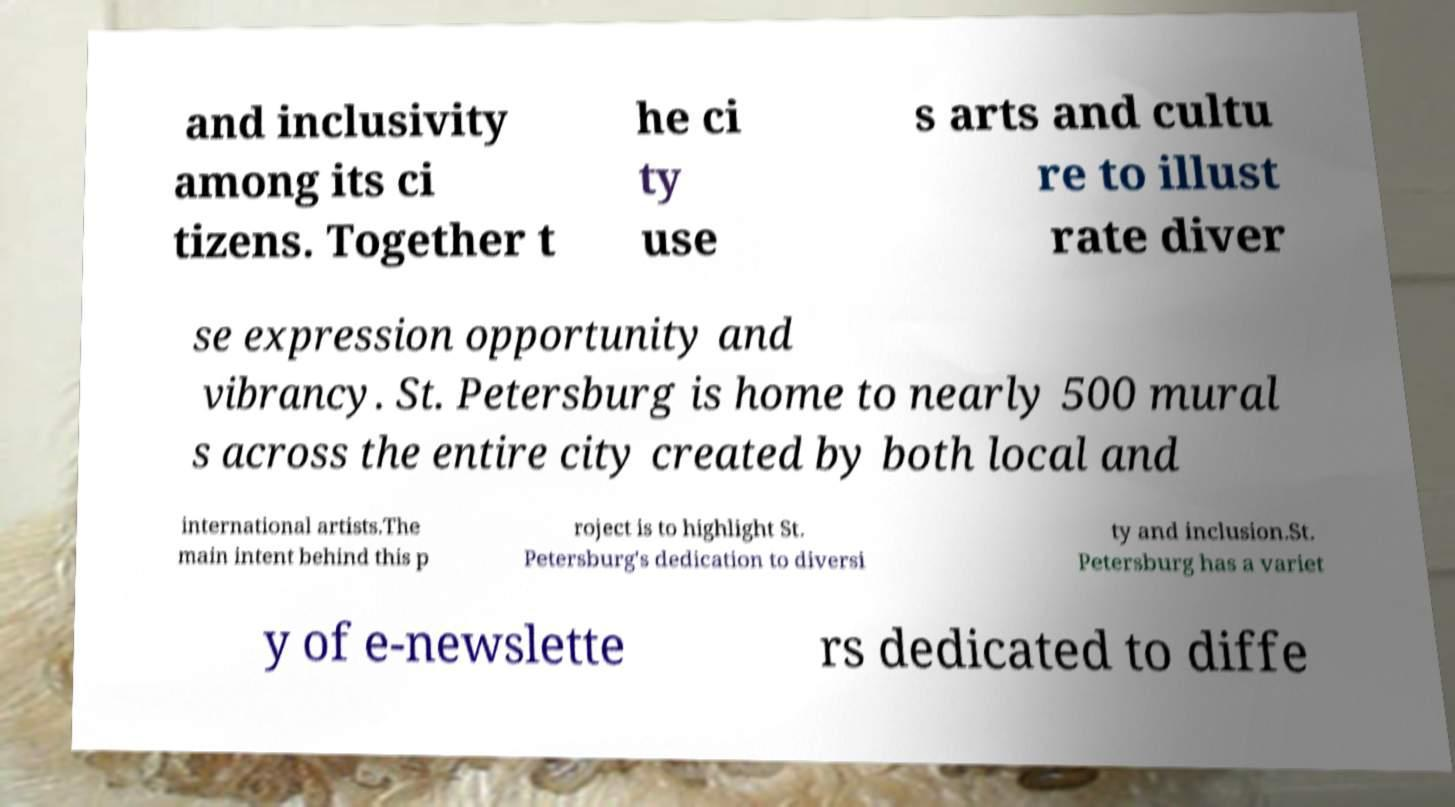I need the written content from this picture converted into text. Can you do that? and inclusivity among its ci tizens. Together t he ci ty use s arts and cultu re to illust rate diver se expression opportunity and vibrancy. St. Petersburg is home to nearly 500 mural s across the entire city created by both local and international artists.The main intent behind this p roject is to highlight St. Petersburg's dedication to diversi ty and inclusion.St. Petersburg has a variet y of e-newslette rs dedicated to diffe 